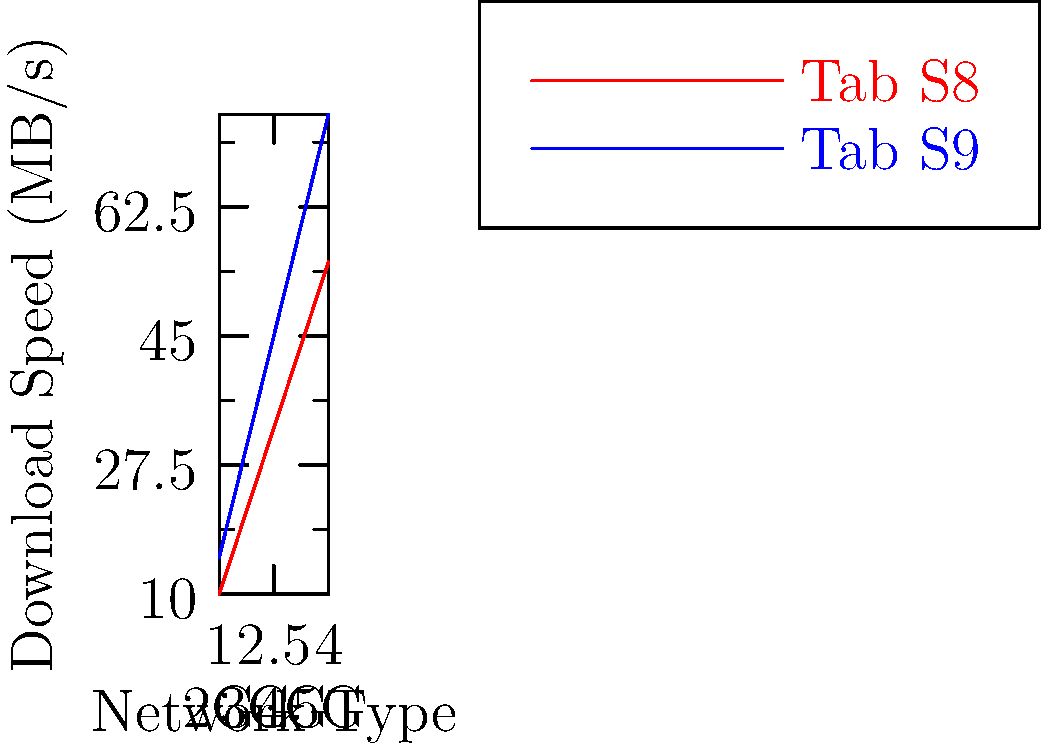Based on the scatter plot comparing download speeds of large files on the Samsung Galaxy Tab S8 and S9 using different network types, what is the approximate difference in download speed between the two devices when using a 5G network? To find the difference in download speed between the Tab S8 and Tab S9 on a 5G network:

1. Identify the 5G data points (rightmost points) for both devices.
2. Tab S8 (red line): The 5G speed is approximately 55 MB/s.
3. Tab S9 (blue line): The 5G speed is approximately 75 MB/s.
4. Calculate the difference: 75 MB/s - 55 MB/s = 20 MB/s.

The Tab S9 is about 20 MB/s faster than the Tab S8 when downloading large files on a 5G network.
Answer: 20 MB/s 